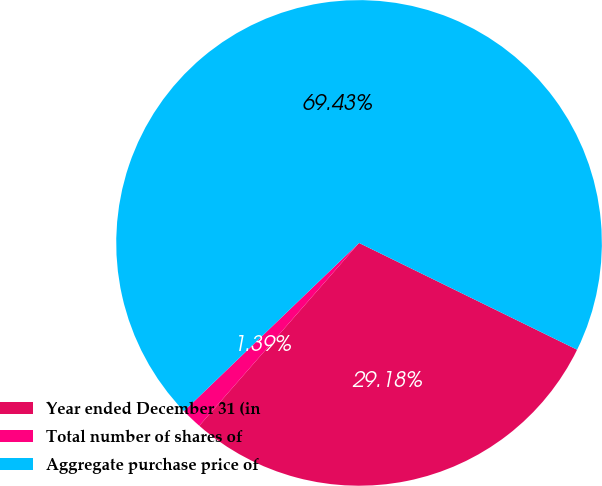Convert chart. <chart><loc_0><loc_0><loc_500><loc_500><pie_chart><fcel>Year ended December 31 (in<fcel>Total number of shares of<fcel>Aggregate purchase price of<nl><fcel>29.18%<fcel>1.39%<fcel>69.42%<nl></chart> 